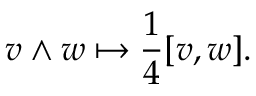Convert formula to latex. <formula><loc_0><loc_0><loc_500><loc_500>v \wedge w \mapsto { \frac { 1 } { 4 } } [ v , w ] .</formula> 